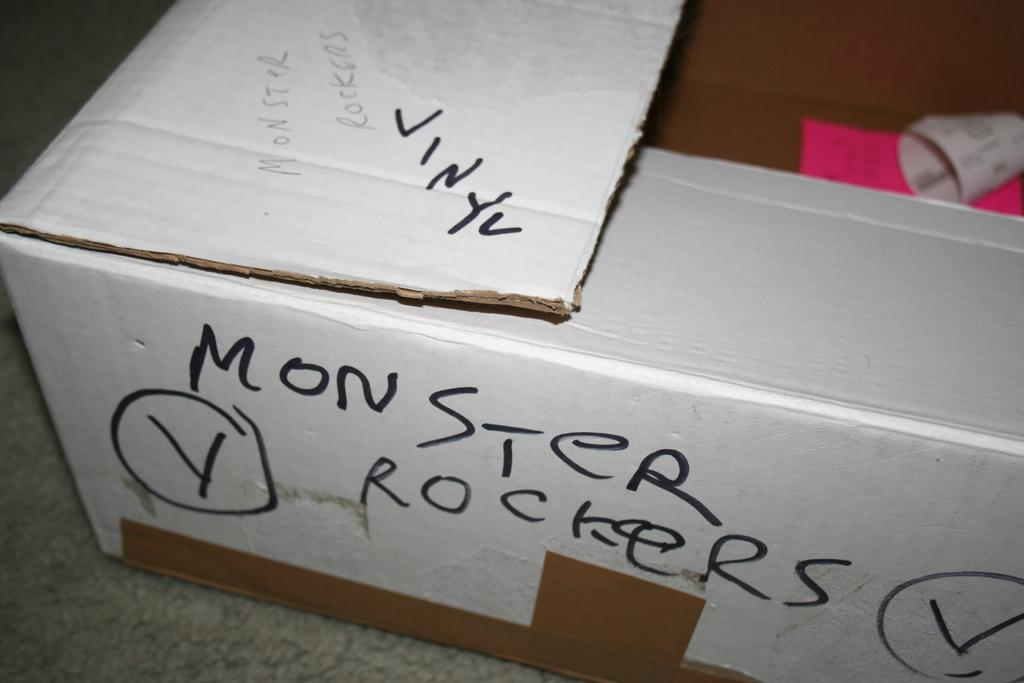<image>
Present a compact description of the photo's key features. The word monster is hand written along the side of this box. 